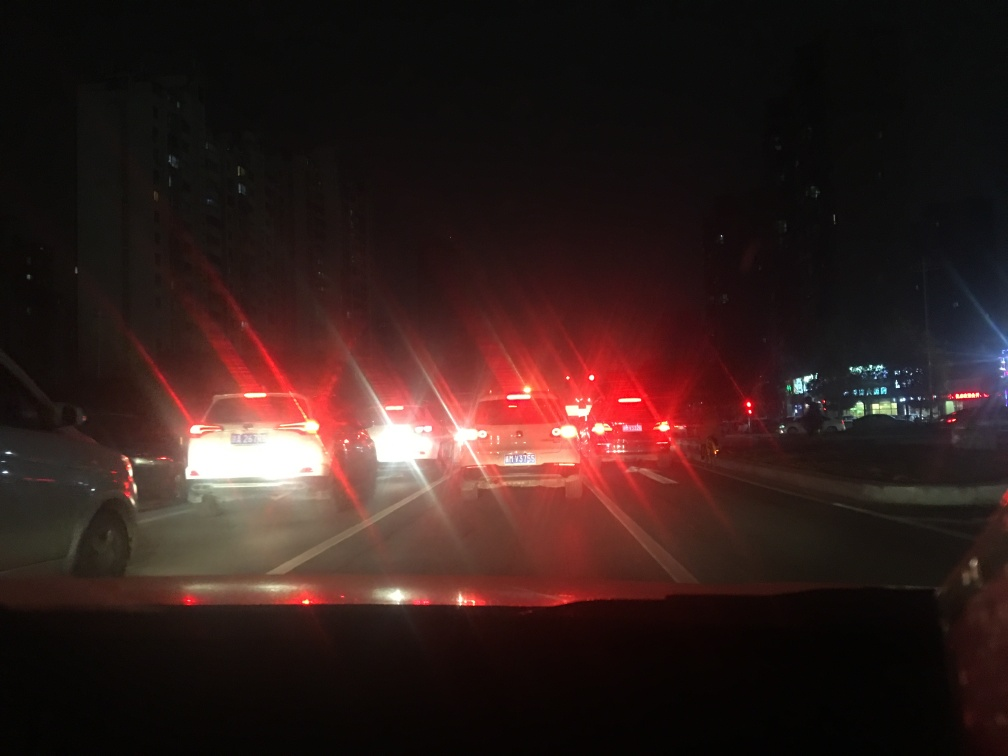Can you describe the scene in this image and suggest what might have been happening when it was taken? The image captures a night-time scene of vehicles stopped, likely at a traffic light or in congested traffic. The brake lights are prominently glowing red, indicating the cars are stationary. Given the brightness of the lights and surrounding darkness, it might have been during late evening hours, when visibility is limited. The driver of the vehicle from which the photo was taken appears to be waiting in line, suggesting a common commute scenario, perhaps everyone heading home after work. 